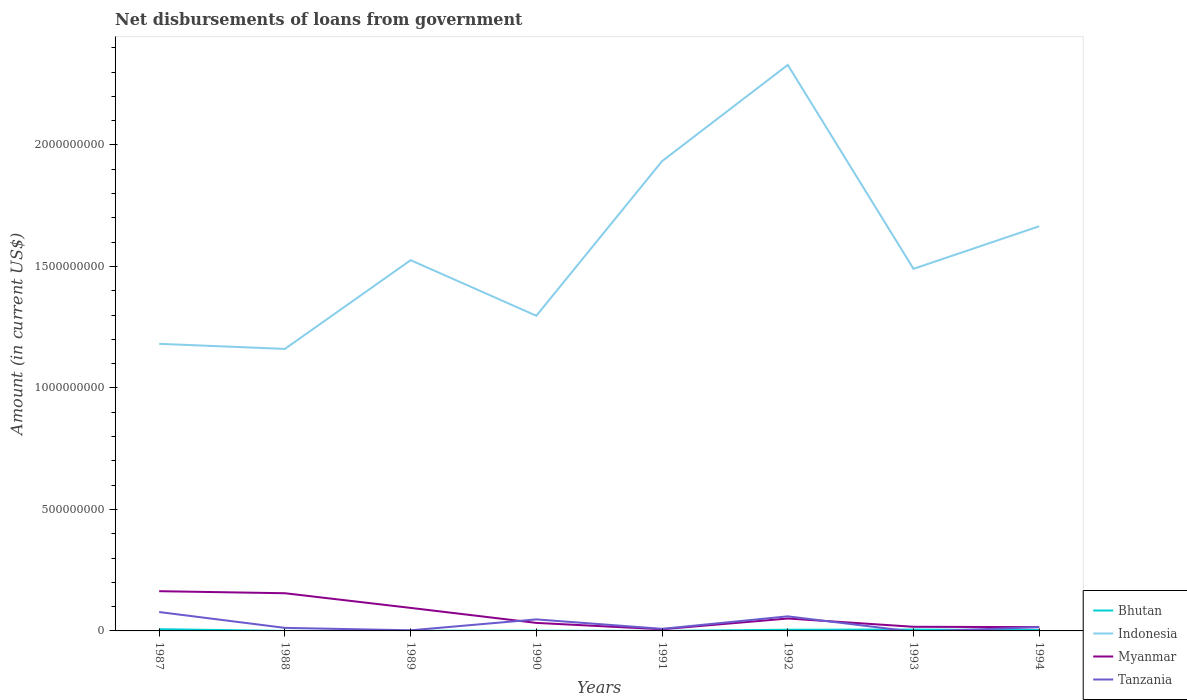How many different coloured lines are there?
Offer a very short reply. 4. Does the line corresponding to Myanmar intersect with the line corresponding to Bhutan?
Give a very brief answer. No. Is the number of lines equal to the number of legend labels?
Your answer should be compact. No. Across all years, what is the maximum amount of loan disbursed from government in Tanzania?
Your answer should be very brief. 0. What is the total amount of loan disbursed from government in Tanzania in the graph?
Provide a short and direct response. 6.51e+07. What is the difference between the highest and the second highest amount of loan disbursed from government in Bhutan?
Offer a very short reply. 7.10e+06. What is the difference between the highest and the lowest amount of loan disbursed from government in Indonesia?
Provide a short and direct response. 3. Is the amount of loan disbursed from government in Myanmar strictly greater than the amount of loan disbursed from government in Bhutan over the years?
Your response must be concise. No. How many lines are there?
Offer a very short reply. 4. What is the difference between two consecutive major ticks on the Y-axis?
Keep it short and to the point. 5.00e+08. Are the values on the major ticks of Y-axis written in scientific E-notation?
Your response must be concise. No. Does the graph contain grids?
Give a very brief answer. No. Where does the legend appear in the graph?
Your answer should be compact. Bottom right. How are the legend labels stacked?
Give a very brief answer. Vertical. What is the title of the graph?
Your response must be concise. Net disbursements of loans from government. What is the Amount (in current US$) of Bhutan in 1987?
Make the answer very short. 7.11e+06. What is the Amount (in current US$) in Indonesia in 1987?
Make the answer very short. 1.18e+09. What is the Amount (in current US$) in Myanmar in 1987?
Provide a succinct answer. 1.64e+08. What is the Amount (in current US$) in Tanzania in 1987?
Your response must be concise. 7.77e+07. What is the Amount (in current US$) of Bhutan in 1988?
Your response must be concise. 7000. What is the Amount (in current US$) in Indonesia in 1988?
Provide a short and direct response. 1.16e+09. What is the Amount (in current US$) of Myanmar in 1988?
Your answer should be very brief. 1.55e+08. What is the Amount (in current US$) of Tanzania in 1988?
Keep it short and to the point. 1.25e+07. What is the Amount (in current US$) in Bhutan in 1989?
Ensure brevity in your answer.  6.94e+05. What is the Amount (in current US$) of Indonesia in 1989?
Your response must be concise. 1.53e+09. What is the Amount (in current US$) in Myanmar in 1989?
Provide a short and direct response. 9.48e+07. What is the Amount (in current US$) in Tanzania in 1989?
Give a very brief answer. 2.54e+06. What is the Amount (in current US$) of Bhutan in 1990?
Your answer should be very brief. 9.27e+05. What is the Amount (in current US$) of Indonesia in 1990?
Offer a very short reply. 1.30e+09. What is the Amount (in current US$) of Myanmar in 1990?
Provide a succinct answer. 3.30e+07. What is the Amount (in current US$) in Tanzania in 1990?
Offer a very short reply. 4.74e+07. What is the Amount (in current US$) in Bhutan in 1991?
Make the answer very short. 6.90e+04. What is the Amount (in current US$) in Indonesia in 1991?
Give a very brief answer. 1.93e+09. What is the Amount (in current US$) of Myanmar in 1991?
Make the answer very short. 6.85e+06. What is the Amount (in current US$) of Tanzania in 1991?
Make the answer very short. 8.54e+06. What is the Amount (in current US$) of Bhutan in 1992?
Your response must be concise. 4.94e+06. What is the Amount (in current US$) in Indonesia in 1992?
Ensure brevity in your answer.  2.33e+09. What is the Amount (in current US$) in Myanmar in 1992?
Provide a succinct answer. 5.11e+07. What is the Amount (in current US$) of Tanzania in 1992?
Your answer should be compact. 6.00e+07. What is the Amount (in current US$) in Bhutan in 1993?
Give a very brief answer. 5.61e+06. What is the Amount (in current US$) of Indonesia in 1993?
Your answer should be compact. 1.49e+09. What is the Amount (in current US$) of Myanmar in 1993?
Offer a terse response. 1.70e+07. What is the Amount (in current US$) of Tanzania in 1993?
Offer a terse response. 0. What is the Amount (in current US$) of Bhutan in 1994?
Provide a succinct answer. 3.74e+06. What is the Amount (in current US$) of Indonesia in 1994?
Make the answer very short. 1.67e+09. What is the Amount (in current US$) of Myanmar in 1994?
Offer a terse response. 1.55e+07. What is the Amount (in current US$) of Tanzania in 1994?
Offer a very short reply. 1.55e+07. Across all years, what is the maximum Amount (in current US$) in Bhutan?
Offer a very short reply. 7.11e+06. Across all years, what is the maximum Amount (in current US$) of Indonesia?
Your response must be concise. 2.33e+09. Across all years, what is the maximum Amount (in current US$) of Myanmar?
Give a very brief answer. 1.64e+08. Across all years, what is the maximum Amount (in current US$) of Tanzania?
Offer a terse response. 7.77e+07. Across all years, what is the minimum Amount (in current US$) in Bhutan?
Your answer should be very brief. 7000. Across all years, what is the minimum Amount (in current US$) in Indonesia?
Your answer should be compact. 1.16e+09. Across all years, what is the minimum Amount (in current US$) of Myanmar?
Your response must be concise. 6.85e+06. What is the total Amount (in current US$) in Bhutan in the graph?
Make the answer very short. 2.31e+07. What is the total Amount (in current US$) of Indonesia in the graph?
Your answer should be compact. 1.26e+1. What is the total Amount (in current US$) in Myanmar in the graph?
Your response must be concise. 5.37e+08. What is the total Amount (in current US$) of Tanzania in the graph?
Make the answer very short. 2.24e+08. What is the difference between the Amount (in current US$) in Bhutan in 1987 and that in 1988?
Provide a succinct answer. 7.10e+06. What is the difference between the Amount (in current US$) of Indonesia in 1987 and that in 1988?
Offer a terse response. 2.09e+07. What is the difference between the Amount (in current US$) of Myanmar in 1987 and that in 1988?
Your answer should be compact. 8.43e+06. What is the difference between the Amount (in current US$) in Tanzania in 1987 and that in 1988?
Ensure brevity in your answer.  6.51e+07. What is the difference between the Amount (in current US$) in Bhutan in 1987 and that in 1989?
Provide a short and direct response. 6.42e+06. What is the difference between the Amount (in current US$) of Indonesia in 1987 and that in 1989?
Your response must be concise. -3.44e+08. What is the difference between the Amount (in current US$) of Myanmar in 1987 and that in 1989?
Your response must be concise. 6.88e+07. What is the difference between the Amount (in current US$) in Tanzania in 1987 and that in 1989?
Make the answer very short. 7.52e+07. What is the difference between the Amount (in current US$) of Bhutan in 1987 and that in 1990?
Make the answer very short. 6.18e+06. What is the difference between the Amount (in current US$) of Indonesia in 1987 and that in 1990?
Your answer should be very brief. -1.16e+08. What is the difference between the Amount (in current US$) in Myanmar in 1987 and that in 1990?
Offer a very short reply. 1.31e+08. What is the difference between the Amount (in current US$) of Tanzania in 1987 and that in 1990?
Offer a very short reply. 3.02e+07. What is the difference between the Amount (in current US$) in Bhutan in 1987 and that in 1991?
Offer a terse response. 7.04e+06. What is the difference between the Amount (in current US$) of Indonesia in 1987 and that in 1991?
Make the answer very short. -7.52e+08. What is the difference between the Amount (in current US$) in Myanmar in 1987 and that in 1991?
Your answer should be very brief. 1.57e+08. What is the difference between the Amount (in current US$) of Tanzania in 1987 and that in 1991?
Offer a terse response. 6.92e+07. What is the difference between the Amount (in current US$) of Bhutan in 1987 and that in 1992?
Offer a terse response. 2.18e+06. What is the difference between the Amount (in current US$) of Indonesia in 1987 and that in 1992?
Offer a very short reply. -1.15e+09. What is the difference between the Amount (in current US$) in Myanmar in 1987 and that in 1992?
Ensure brevity in your answer.  1.12e+08. What is the difference between the Amount (in current US$) in Tanzania in 1987 and that in 1992?
Give a very brief answer. 1.77e+07. What is the difference between the Amount (in current US$) of Bhutan in 1987 and that in 1993?
Keep it short and to the point. 1.50e+06. What is the difference between the Amount (in current US$) in Indonesia in 1987 and that in 1993?
Ensure brevity in your answer.  -3.09e+08. What is the difference between the Amount (in current US$) in Myanmar in 1987 and that in 1993?
Make the answer very short. 1.47e+08. What is the difference between the Amount (in current US$) in Bhutan in 1987 and that in 1994?
Provide a succinct answer. 3.37e+06. What is the difference between the Amount (in current US$) in Indonesia in 1987 and that in 1994?
Ensure brevity in your answer.  -4.84e+08. What is the difference between the Amount (in current US$) of Myanmar in 1987 and that in 1994?
Ensure brevity in your answer.  1.48e+08. What is the difference between the Amount (in current US$) in Tanzania in 1987 and that in 1994?
Give a very brief answer. 6.22e+07. What is the difference between the Amount (in current US$) of Bhutan in 1988 and that in 1989?
Make the answer very short. -6.87e+05. What is the difference between the Amount (in current US$) of Indonesia in 1988 and that in 1989?
Give a very brief answer. -3.65e+08. What is the difference between the Amount (in current US$) in Myanmar in 1988 and that in 1989?
Offer a terse response. 6.04e+07. What is the difference between the Amount (in current US$) of Tanzania in 1988 and that in 1989?
Provide a succinct answer. 1.00e+07. What is the difference between the Amount (in current US$) of Bhutan in 1988 and that in 1990?
Ensure brevity in your answer.  -9.20e+05. What is the difference between the Amount (in current US$) of Indonesia in 1988 and that in 1990?
Provide a short and direct response. -1.36e+08. What is the difference between the Amount (in current US$) in Myanmar in 1988 and that in 1990?
Provide a succinct answer. 1.22e+08. What is the difference between the Amount (in current US$) in Tanzania in 1988 and that in 1990?
Make the answer very short. -3.49e+07. What is the difference between the Amount (in current US$) in Bhutan in 1988 and that in 1991?
Provide a short and direct response. -6.20e+04. What is the difference between the Amount (in current US$) of Indonesia in 1988 and that in 1991?
Keep it short and to the point. -7.73e+08. What is the difference between the Amount (in current US$) of Myanmar in 1988 and that in 1991?
Ensure brevity in your answer.  1.48e+08. What is the difference between the Amount (in current US$) in Tanzania in 1988 and that in 1991?
Provide a succinct answer. 4.00e+06. What is the difference between the Amount (in current US$) in Bhutan in 1988 and that in 1992?
Your response must be concise. -4.93e+06. What is the difference between the Amount (in current US$) of Indonesia in 1988 and that in 1992?
Provide a short and direct response. -1.17e+09. What is the difference between the Amount (in current US$) of Myanmar in 1988 and that in 1992?
Make the answer very short. 1.04e+08. What is the difference between the Amount (in current US$) of Tanzania in 1988 and that in 1992?
Provide a short and direct response. -4.74e+07. What is the difference between the Amount (in current US$) in Bhutan in 1988 and that in 1993?
Make the answer very short. -5.60e+06. What is the difference between the Amount (in current US$) in Indonesia in 1988 and that in 1993?
Ensure brevity in your answer.  -3.30e+08. What is the difference between the Amount (in current US$) in Myanmar in 1988 and that in 1993?
Provide a short and direct response. 1.38e+08. What is the difference between the Amount (in current US$) in Bhutan in 1988 and that in 1994?
Make the answer very short. -3.73e+06. What is the difference between the Amount (in current US$) in Indonesia in 1988 and that in 1994?
Offer a terse response. -5.05e+08. What is the difference between the Amount (in current US$) in Myanmar in 1988 and that in 1994?
Make the answer very short. 1.40e+08. What is the difference between the Amount (in current US$) of Tanzania in 1988 and that in 1994?
Offer a very short reply. -2.97e+06. What is the difference between the Amount (in current US$) of Bhutan in 1989 and that in 1990?
Offer a terse response. -2.33e+05. What is the difference between the Amount (in current US$) of Indonesia in 1989 and that in 1990?
Ensure brevity in your answer.  2.29e+08. What is the difference between the Amount (in current US$) of Myanmar in 1989 and that in 1990?
Your answer should be very brief. 6.18e+07. What is the difference between the Amount (in current US$) of Tanzania in 1989 and that in 1990?
Your answer should be very brief. -4.49e+07. What is the difference between the Amount (in current US$) in Bhutan in 1989 and that in 1991?
Your answer should be very brief. 6.25e+05. What is the difference between the Amount (in current US$) in Indonesia in 1989 and that in 1991?
Make the answer very short. -4.08e+08. What is the difference between the Amount (in current US$) of Myanmar in 1989 and that in 1991?
Offer a very short reply. 8.79e+07. What is the difference between the Amount (in current US$) in Tanzania in 1989 and that in 1991?
Provide a succinct answer. -6.00e+06. What is the difference between the Amount (in current US$) in Bhutan in 1989 and that in 1992?
Offer a very short reply. -4.24e+06. What is the difference between the Amount (in current US$) of Indonesia in 1989 and that in 1992?
Make the answer very short. -8.04e+08. What is the difference between the Amount (in current US$) in Myanmar in 1989 and that in 1992?
Your answer should be very brief. 4.37e+07. What is the difference between the Amount (in current US$) of Tanzania in 1989 and that in 1992?
Offer a terse response. -5.74e+07. What is the difference between the Amount (in current US$) of Bhutan in 1989 and that in 1993?
Offer a very short reply. -4.92e+06. What is the difference between the Amount (in current US$) in Indonesia in 1989 and that in 1993?
Keep it short and to the point. 3.55e+07. What is the difference between the Amount (in current US$) in Myanmar in 1989 and that in 1993?
Make the answer very short. 7.77e+07. What is the difference between the Amount (in current US$) of Bhutan in 1989 and that in 1994?
Keep it short and to the point. -3.05e+06. What is the difference between the Amount (in current US$) in Indonesia in 1989 and that in 1994?
Your answer should be very brief. -1.40e+08. What is the difference between the Amount (in current US$) in Myanmar in 1989 and that in 1994?
Provide a short and direct response. 7.92e+07. What is the difference between the Amount (in current US$) of Tanzania in 1989 and that in 1994?
Make the answer very short. -1.30e+07. What is the difference between the Amount (in current US$) of Bhutan in 1990 and that in 1991?
Give a very brief answer. 8.58e+05. What is the difference between the Amount (in current US$) in Indonesia in 1990 and that in 1991?
Provide a succinct answer. -6.36e+08. What is the difference between the Amount (in current US$) in Myanmar in 1990 and that in 1991?
Give a very brief answer. 2.62e+07. What is the difference between the Amount (in current US$) in Tanzania in 1990 and that in 1991?
Offer a terse response. 3.89e+07. What is the difference between the Amount (in current US$) in Bhutan in 1990 and that in 1992?
Your response must be concise. -4.01e+06. What is the difference between the Amount (in current US$) of Indonesia in 1990 and that in 1992?
Your response must be concise. -1.03e+09. What is the difference between the Amount (in current US$) in Myanmar in 1990 and that in 1992?
Your answer should be very brief. -1.81e+07. What is the difference between the Amount (in current US$) in Tanzania in 1990 and that in 1992?
Your response must be concise. -1.25e+07. What is the difference between the Amount (in current US$) in Bhutan in 1990 and that in 1993?
Offer a very short reply. -4.68e+06. What is the difference between the Amount (in current US$) in Indonesia in 1990 and that in 1993?
Make the answer very short. -1.93e+08. What is the difference between the Amount (in current US$) of Myanmar in 1990 and that in 1993?
Your answer should be compact. 1.60e+07. What is the difference between the Amount (in current US$) in Bhutan in 1990 and that in 1994?
Offer a very short reply. -2.81e+06. What is the difference between the Amount (in current US$) of Indonesia in 1990 and that in 1994?
Your answer should be very brief. -3.68e+08. What is the difference between the Amount (in current US$) of Myanmar in 1990 and that in 1994?
Ensure brevity in your answer.  1.75e+07. What is the difference between the Amount (in current US$) of Tanzania in 1990 and that in 1994?
Give a very brief answer. 3.19e+07. What is the difference between the Amount (in current US$) of Bhutan in 1991 and that in 1992?
Provide a short and direct response. -4.87e+06. What is the difference between the Amount (in current US$) of Indonesia in 1991 and that in 1992?
Your answer should be compact. -3.96e+08. What is the difference between the Amount (in current US$) in Myanmar in 1991 and that in 1992?
Keep it short and to the point. -4.42e+07. What is the difference between the Amount (in current US$) of Tanzania in 1991 and that in 1992?
Make the answer very short. -5.14e+07. What is the difference between the Amount (in current US$) in Bhutan in 1991 and that in 1993?
Offer a terse response. -5.54e+06. What is the difference between the Amount (in current US$) of Indonesia in 1991 and that in 1993?
Offer a very short reply. 4.43e+08. What is the difference between the Amount (in current US$) of Myanmar in 1991 and that in 1993?
Provide a succinct answer. -1.02e+07. What is the difference between the Amount (in current US$) in Bhutan in 1991 and that in 1994?
Give a very brief answer. -3.67e+06. What is the difference between the Amount (in current US$) of Indonesia in 1991 and that in 1994?
Your answer should be compact. 2.68e+08. What is the difference between the Amount (in current US$) of Myanmar in 1991 and that in 1994?
Offer a terse response. -8.68e+06. What is the difference between the Amount (in current US$) in Tanzania in 1991 and that in 1994?
Ensure brevity in your answer.  -6.98e+06. What is the difference between the Amount (in current US$) of Bhutan in 1992 and that in 1993?
Ensure brevity in your answer.  -6.75e+05. What is the difference between the Amount (in current US$) of Indonesia in 1992 and that in 1993?
Ensure brevity in your answer.  8.39e+08. What is the difference between the Amount (in current US$) in Myanmar in 1992 and that in 1993?
Keep it short and to the point. 3.41e+07. What is the difference between the Amount (in current US$) of Bhutan in 1992 and that in 1994?
Keep it short and to the point. 1.20e+06. What is the difference between the Amount (in current US$) in Indonesia in 1992 and that in 1994?
Ensure brevity in your answer.  6.64e+08. What is the difference between the Amount (in current US$) in Myanmar in 1992 and that in 1994?
Ensure brevity in your answer.  3.56e+07. What is the difference between the Amount (in current US$) in Tanzania in 1992 and that in 1994?
Offer a terse response. 4.45e+07. What is the difference between the Amount (in current US$) of Bhutan in 1993 and that in 1994?
Give a very brief answer. 1.87e+06. What is the difference between the Amount (in current US$) in Indonesia in 1993 and that in 1994?
Offer a very short reply. -1.75e+08. What is the difference between the Amount (in current US$) in Myanmar in 1993 and that in 1994?
Give a very brief answer. 1.50e+06. What is the difference between the Amount (in current US$) in Bhutan in 1987 and the Amount (in current US$) in Indonesia in 1988?
Keep it short and to the point. -1.15e+09. What is the difference between the Amount (in current US$) in Bhutan in 1987 and the Amount (in current US$) in Myanmar in 1988?
Your response must be concise. -1.48e+08. What is the difference between the Amount (in current US$) in Bhutan in 1987 and the Amount (in current US$) in Tanzania in 1988?
Keep it short and to the point. -5.44e+06. What is the difference between the Amount (in current US$) of Indonesia in 1987 and the Amount (in current US$) of Myanmar in 1988?
Keep it short and to the point. 1.03e+09. What is the difference between the Amount (in current US$) in Indonesia in 1987 and the Amount (in current US$) in Tanzania in 1988?
Offer a very short reply. 1.17e+09. What is the difference between the Amount (in current US$) in Myanmar in 1987 and the Amount (in current US$) in Tanzania in 1988?
Your response must be concise. 1.51e+08. What is the difference between the Amount (in current US$) of Bhutan in 1987 and the Amount (in current US$) of Indonesia in 1989?
Your answer should be compact. -1.52e+09. What is the difference between the Amount (in current US$) in Bhutan in 1987 and the Amount (in current US$) in Myanmar in 1989?
Offer a terse response. -8.77e+07. What is the difference between the Amount (in current US$) in Bhutan in 1987 and the Amount (in current US$) in Tanzania in 1989?
Provide a short and direct response. 4.57e+06. What is the difference between the Amount (in current US$) of Indonesia in 1987 and the Amount (in current US$) of Myanmar in 1989?
Your answer should be compact. 1.09e+09. What is the difference between the Amount (in current US$) in Indonesia in 1987 and the Amount (in current US$) in Tanzania in 1989?
Keep it short and to the point. 1.18e+09. What is the difference between the Amount (in current US$) of Myanmar in 1987 and the Amount (in current US$) of Tanzania in 1989?
Make the answer very short. 1.61e+08. What is the difference between the Amount (in current US$) in Bhutan in 1987 and the Amount (in current US$) in Indonesia in 1990?
Your response must be concise. -1.29e+09. What is the difference between the Amount (in current US$) in Bhutan in 1987 and the Amount (in current US$) in Myanmar in 1990?
Your answer should be compact. -2.59e+07. What is the difference between the Amount (in current US$) in Bhutan in 1987 and the Amount (in current US$) in Tanzania in 1990?
Your answer should be very brief. -4.03e+07. What is the difference between the Amount (in current US$) in Indonesia in 1987 and the Amount (in current US$) in Myanmar in 1990?
Provide a succinct answer. 1.15e+09. What is the difference between the Amount (in current US$) in Indonesia in 1987 and the Amount (in current US$) in Tanzania in 1990?
Offer a terse response. 1.13e+09. What is the difference between the Amount (in current US$) in Myanmar in 1987 and the Amount (in current US$) in Tanzania in 1990?
Your answer should be very brief. 1.16e+08. What is the difference between the Amount (in current US$) of Bhutan in 1987 and the Amount (in current US$) of Indonesia in 1991?
Your answer should be very brief. -1.93e+09. What is the difference between the Amount (in current US$) of Bhutan in 1987 and the Amount (in current US$) of Myanmar in 1991?
Offer a very short reply. 2.64e+05. What is the difference between the Amount (in current US$) in Bhutan in 1987 and the Amount (in current US$) in Tanzania in 1991?
Keep it short and to the point. -1.43e+06. What is the difference between the Amount (in current US$) in Indonesia in 1987 and the Amount (in current US$) in Myanmar in 1991?
Your response must be concise. 1.17e+09. What is the difference between the Amount (in current US$) of Indonesia in 1987 and the Amount (in current US$) of Tanzania in 1991?
Give a very brief answer. 1.17e+09. What is the difference between the Amount (in current US$) of Myanmar in 1987 and the Amount (in current US$) of Tanzania in 1991?
Keep it short and to the point. 1.55e+08. What is the difference between the Amount (in current US$) in Bhutan in 1987 and the Amount (in current US$) in Indonesia in 1992?
Keep it short and to the point. -2.32e+09. What is the difference between the Amount (in current US$) in Bhutan in 1987 and the Amount (in current US$) in Myanmar in 1992?
Offer a very short reply. -4.40e+07. What is the difference between the Amount (in current US$) of Bhutan in 1987 and the Amount (in current US$) of Tanzania in 1992?
Provide a succinct answer. -5.29e+07. What is the difference between the Amount (in current US$) in Indonesia in 1987 and the Amount (in current US$) in Myanmar in 1992?
Provide a succinct answer. 1.13e+09. What is the difference between the Amount (in current US$) in Indonesia in 1987 and the Amount (in current US$) in Tanzania in 1992?
Ensure brevity in your answer.  1.12e+09. What is the difference between the Amount (in current US$) of Myanmar in 1987 and the Amount (in current US$) of Tanzania in 1992?
Provide a short and direct response. 1.04e+08. What is the difference between the Amount (in current US$) of Bhutan in 1987 and the Amount (in current US$) of Indonesia in 1993?
Ensure brevity in your answer.  -1.48e+09. What is the difference between the Amount (in current US$) of Bhutan in 1987 and the Amount (in current US$) of Myanmar in 1993?
Offer a very short reply. -9.92e+06. What is the difference between the Amount (in current US$) in Indonesia in 1987 and the Amount (in current US$) in Myanmar in 1993?
Offer a very short reply. 1.16e+09. What is the difference between the Amount (in current US$) in Bhutan in 1987 and the Amount (in current US$) in Indonesia in 1994?
Give a very brief answer. -1.66e+09. What is the difference between the Amount (in current US$) of Bhutan in 1987 and the Amount (in current US$) of Myanmar in 1994?
Provide a succinct answer. -8.42e+06. What is the difference between the Amount (in current US$) in Bhutan in 1987 and the Amount (in current US$) in Tanzania in 1994?
Provide a short and direct response. -8.41e+06. What is the difference between the Amount (in current US$) in Indonesia in 1987 and the Amount (in current US$) in Myanmar in 1994?
Your answer should be very brief. 1.17e+09. What is the difference between the Amount (in current US$) in Indonesia in 1987 and the Amount (in current US$) in Tanzania in 1994?
Keep it short and to the point. 1.17e+09. What is the difference between the Amount (in current US$) in Myanmar in 1987 and the Amount (in current US$) in Tanzania in 1994?
Provide a short and direct response. 1.48e+08. What is the difference between the Amount (in current US$) in Bhutan in 1988 and the Amount (in current US$) in Indonesia in 1989?
Keep it short and to the point. -1.53e+09. What is the difference between the Amount (in current US$) of Bhutan in 1988 and the Amount (in current US$) of Myanmar in 1989?
Keep it short and to the point. -9.48e+07. What is the difference between the Amount (in current US$) in Bhutan in 1988 and the Amount (in current US$) in Tanzania in 1989?
Offer a very short reply. -2.53e+06. What is the difference between the Amount (in current US$) of Indonesia in 1988 and the Amount (in current US$) of Myanmar in 1989?
Provide a succinct answer. 1.07e+09. What is the difference between the Amount (in current US$) in Indonesia in 1988 and the Amount (in current US$) in Tanzania in 1989?
Provide a short and direct response. 1.16e+09. What is the difference between the Amount (in current US$) in Myanmar in 1988 and the Amount (in current US$) in Tanzania in 1989?
Your response must be concise. 1.53e+08. What is the difference between the Amount (in current US$) in Bhutan in 1988 and the Amount (in current US$) in Indonesia in 1990?
Offer a terse response. -1.30e+09. What is the difference between the Amount (in current US$) of Bhutan in 1988 and the Amount (in current US$) of Myanmar in 1990?
Keep it short and to the point. -3.30e+07. What is the difference between the Amount (in current US$) of Bhutan in 1988 and the Amount (in current US$) of Tanzania in 1990?
Ensure brevity in your answer.  -4.74e+07. What is the difference between the Amount (in current US$) of Indonesia in 1988 and the Amount (in current US$) of Myanmar in 1990?
Provide a succinct answer. 1.13e+09. What is the difference between the Amount (in current US$) of Indonesia in 1988 and the Amount (in current US$) of Tanzania in 1990?
Offer a terse response. 1.11e+09. What is the difference between the Amount (in current US$) of Myanmar in 1988 and the Amount (in current US$) of Tanzania in 1990?
Your answer should be very brief. 1.08e+08. What is the difference between the Amount (in current US$) of Bhutan in 1988 and the Amount (in current US$) of Indonesia in 1991?
Give a very brief answer. -1.93e+09. What is the difference between the Amount (in current US$) of Bhutan in 1988 and the Amount (in current US$) of Myanmar in 1991?
Give a very brief answer. -6.84e+06. What is the difference between the Amount (in current US$) in Bhutan in 1988 and the Amount (in current US$) in Tanzania in 1991?
Ensure brevity in your answer.  -8.54e+06. What is the difference between the Amount (in current US$) in Indonesia in 1988 and the Amount (in current US$) in Myanmar in 1991?
Provide a succinct answer. 1.15e+09. What is the difference between the Amount (in current US$) in Indonesia in 1988 and the Amount (in current US$) in Tanzania in 1991?
Offer a terse response. 1.15e+09. What is the difference between the Amount (in current US$) of Myanmar in 1988 and the Amount (in current US$) of Tanzania in 1991?
Offer a very short reply. 1.47e+08. What is the difference between the Amount (in current US$) of Bhutan in 1988 and the Amount (in current US$) of Indonesia in 1992?
Make the answer very short. -2.33e+09. What is the difference between the Amount (in current US$) of Bhutan in 1988 and the Amount (in current US$) of Myanmar in 1992?
Your answer should be very brief. -5.11e+07. What is the difference between the Amount (in current US$) of Bhutan in 1988 and the Amount (in current US$) of Tanzania in 1992?
Provide a succinct answer. -6.00e+07. What is the difference between the Amount (in current US$) in Indonesia in 1988 and the Amount (in current US$) in Myanmar in 1992?
Provide a short and direct response. 1.11e+09. What is the difference between the Amount (in current US$) in Indonesia in 1988 and the Amount (in current US$) in Tanzania in 1992?
Provide a short and direct response. 1.10e+09. What is the difference between the Amount (in current US$) in Myanmar in 1988 and the Amount (in current US$) in Tanzania in 1992?
Offer a terse response. 9.51e+07. What is the difference between the Amount (in current US$) of Bhutan in 1988 and the Amount (in current US$) of Indonesia in 1993?
Provide a short and direct response. -1.49e+09. What is the difference between the Amount (in current US$) in Bhutan in 1988 and the Amount (in current US$) in Myanmar in 1993?
Make the answer very short. -1.70e+07. What is the difference between the Amount (in current US$) in Indonesia in 1988 and the Amount (in current US$) in Myanmar in 1993?
Provide a succinct answer. 1.14e+09. What is the difference between the Amount (in current US$) in Bhutan in 1988 and the Amount (in current US$) in Indonesia in 1994?
Ensure brevity in your answer.  -1.67e+09. What is the difference between the Amount (in current US$) of Bhutan in 1988 and the Amount (in current US$) of Myanmar in 1994?
Your answer should be compact. -1.55e+07. What is the difference between the Amount (in current US$) in Bhutan in 1988 and the Amount (in current US$) in Tanzania in 1994?
Offer a terse response. -1.55e+07. What is the difference between the Amount (in current US$) in Indonesia in 1988 and the Amount (in current US$) in Myanmar in 1994?
Make the answer very short. 1.15e+09. What is the difference between the Amount (in current US$) in Indonesia in 1988 and the Amount (in current US$) in Tanzania in 1994?
Give a very brief answer. 1.15e+09. What is the difference between the Amount (in current US$) in Myanmar in 1988 and the Amount (in current US$) in Tanzania in 1994?
Ensure brevity in your answer.  1.40e+08. What is the difference between the Amount (in current US$) of Bhutan in 1989 and the Amount (in current US$) of Indonesia in 1990?
Your answer should be very brief. -1.30e+09. What is the difference between the Amount (in current US$) in Bhutan in 1989 and the Amount (in current US$) in Myanmar in 1990?
Provide a succinct answer. -3.23e+07. What is the difference between the Amount (in current US$) in Bhutan in 1989 and the Amount (in current US$) in Tanzania in 1990?
Provide a short and direct response. -4.68e+07. What is the difference between the Amount (in current US$) of Indonesia in 1989 and the Amount (in current US$) of Myanmar in 1990?
Offer a terse response. 1.49e+09. What is the difference between the Amount (in current US$) of Indonesia in 1989 and the Amount (in current US$) of Tanzania in 1990?
Your answer should be compact. 1.48e+09. What is the difference between the Amount (in current US$) of Myanmar in 1989 and the Amount (in current US$) of Tanzania in 1990?
Give a very brief answer. 4.73e+07. What is the difference between the Amount (in current US$) in Bhutan in 1989 and the Amount (in current US$) in Indonesia in 1991?
Offer a very short reply. -1.93e+09. What is the difference between the Amount (in current US$) in Bhutan in 1989 and the Amount (in current US$) in Myanmar in 1991?
Keep it short and to the point. -6.15e+06. What is the difference between the Amount (in current US$) of Bhutan in 1989 and the Amount (in current US$) of Tanzania in 1991?
Provide a short and direct response. -7.85e+06. What is the difference between the Amount (in current US$) of Indonesia in 1989 and the Amount (in current US$) of Myanmar in 1991?
Your answer should be very brief. 1.52e+09. What is the difference between the Amount (in current US$) of Indonesia in 1989 and the Amount (in current US$) of Tanzania in 1991?
Ensure brevity in your answer.  1.52e+09. What is the difference between the Amount (in current US$) in Myanmar in 1989 and the Amount (in current US$) in Tanzania in 1991?
Provide a short and direct response. 8.62e+07. What is the difference between the Amount (in current US$) of Bhutan in 1989 and the Amount (in current US$) of Indonesia in 1992?
Offer a terse response. -2.33e+09. What is the difference between the Amount (in current US$) in Bhutan in 1989 and the Amount (in current US$) in Myanmar in 1992?
Your response must be concise. -5.04e+07. What is the difference between the Amount (in current US$) of Bhutan in 1989 and the Amount (in current US$) of Tanzania in 1992?
Make the answer very short. -5.93e+07. What is the difference between the Amount (in current US$) in Indonesia in 1989 and the Amount (in current US$) in Myanmar in 1992?
Offer a very short reply. 1.47e+09. What is the difference between the Amount (in current US$) in Indonesia in 1989 and the Amount (in current US$) in Tanzania in 1992?
Ensure brevity in your answer.  1.47e+09. What is the difference between the Amount (in current US$) in Myanmar in 1989 and the Amount (in current US$) in Tanzania in 1992?
Provide a short and direct response. 3.48e+07. What is the difference between the Amount (in current US$) of Bhutan in 1989 and the Amount (in current US$) of Indonesia in 1993?
Offer a terse response. -1.49e+09. What is the difference between the Amount (in current US$) of Bhutan in 1989 and the Amount (in current US$) of Myanmar in 1993?
Your answer should be compact. -1.63e+07. What is the difference between the Amount (in current US$) in Indonesia in 1989 and the Amount (in current US$) in Myanmar in 1993?
Make the answer very short. 1.51e+09. What is the difference between the Amount (in current US$) of Bhutan in 1989 and the Amount (in current US$) of Indonesia in 1994?
Provide a succinct answer. -1.66e+09. What is the difference between the Amount (in current US$) in Bhutan in 1989 and the Amount (in current US$) in Myanmar in 1994?
Ensure brevity in your answer.  -1.48e+07. What is the difference between the Amount (in current US$) of Bhutan in 1989 and the Amount (in current US$) of Tanzania in 1994?
Your response must be concise. -1.48e+07. What is the difference between the Amount (in current US$) in Indonesia in 1989 and the Amount (in current US$) in Myanmar in 1994?
Your response must be concise. 1.51e+09. What is the difference between the Amount (in current US$) of Indonesia in 1989 and the Amount (in current US$) of Tanzania in 1994?
Your response must be concise. 1.51e+09. What is the difference between the Amount (in current US$) in Myanmar in 1989 and the Amount (in current US$) in Tanzania in 1994?
Make the answer very short. 7.92e+07. What is the difference between the Amount (in current US$) in Bhutan in 1990 and the Amount (in current US$) in Indonesia in 1991?
Give a very brief answer. -1.93e+09. What is the difference between the Amount (in current US$) in Bhutan in 1990 and the Amount (in current US$) in Myanmar in 1991?
Provide a short and direct response. -5.92e+06. What is the difference between the Amount (in current US$) in Bhutan in 1990 and the Amount (in current US$) in Tanzania in 1991?
Your response must be concise. -7.62e+06. What is the difference between the Amount (in current US$) in Indonesia in 1990 and the Amount (in current US$) in Myanmar in 1991?
Your response must be concise. 1.29e+09. What is the difference between the Amount (in current US$) in Indonesia in 1990 and the Amount (in current US$) in Tanzania in 1991?
Your answer should be very brief. 1.29e+09. What is the difference between the Amount (in current US$) in Myanmar in 1990 and the Amount (in current US$) in Tanzania in 1991?
Ensure brevity in your answer.  2.45e+07. What is the difference between the Amount (in current US$) in Bhutan in 1990 and the Amount (in current US$) in Indonesia in 1992?
Offer a very short reply. -2.33e+09. What is the difference between the Amount (in current US$) of Bhutan in 1990 and the Amount (in current US$) of Myanmar in 1992?
Provide a succinct answer. -5.02e+07. What is the difference between the Amount (in current US$) of Bhutan in 1990 and the Amount (in current US$) of Tanzania in 1992?
Ensure brevity in your answer.  -5.91e+07. What is the difference between the Amount (in current US$) of Indonesia in 1990 and the Amount (in current US$) of Myanmar in 1992?
Your response must be concise. 1.25e+09. What is the difference between the Amount (in current US$) of Indonesia in 1990 and the Amount (in current US$) of Tanzania in 1992?
Your answer should be very brief. 1.24e+09. What is the difference between the Amount (in current US$) in Myanmar in 1990 and the Amount (in current US$) in Tanzania in 1992?
Your answer should be compact. -2.70e+07. What is the difference between the Amount (in current US$) of Bhutan in 1990 and the Amount (in current US$) of Indonesia in 1993?
Ensure brevity in your answer.  -1.49e+09. What is the difference between the Amount (in current US$) in Bhutan in 1990 and the Amount (in current US$) in Myanmar in 1993?
Give a very brief answer. -1.61e+07. What is the difference between the Amount (in current US$) of Indonesia in 1990 and the Amount (in current US$) of Myanmar in 1993?
Make the answer very short. 1.28e+09. What is the difference between the Amount (in current US$) of Bhutan in 1990 and the Amount (in current US$) of Indonesia in 1994?
Make the answer very short. -1.66e+09. What is the difference between the Amount (in current US$) in Bhutan in 1990 and the Amount (in current US$) in Myanmar in 1994?
Offer a very short reply. -1.46e+07. What is the difference between the Amount (in current US$) of Bhutan in 1990 and the Amount (in current US$) of Tanzania in 1994?
Your response must be concise. -1.46e+07. What is the difference between the Amount (in current US$) in Indonesia in 1990 and the Amount (in current US$) in Myanmar in 1994?
Ensure brevity in your answer.  1.28e+09. What is the difference between the Amount (in current US$) of Indonesia in 1990 and the Amount (in current US$) of Tanzania in 1994?
Offer a very short reply. 1.28e+09. What is the difference between the Amount (in current US$) in Myanmar in 1990 and the Amount (in current US$) in Tanzania in 1994?
Your answer should be compact. 1.75e+07. What is the difference between the Amount (in current US$) in Bhutan in 1991 and the Amount (in current US$) in Indonesia in 1992?
Offer a very short reply. -2.33e+09. What is the difference between the Amount (in current US$) of Bhutan in 1991 and the Amount (in current US$) of Myanmar in 1992?
Make the answer very short. -5.10e+07. What is the difference between the Amount (in current US$) of Bhutan in 1991 and the Amount (in current US$) of Tanzania in 1992?
Keep it short and to the point. -5.99e+07. What is the difference between the Amount (in current US$) in Indonesia in 1991 and the Amount (in current US$) in Myanmar in 1992?
Provide a succinct answer. 1.88e+09. What is the difference between the Amount (in current US$) of Indonesia in 1991 and the Amount (in current US$) of Tanzania in 1992?
Offer a terse response. 1.87e+09. What is the difference between the Amount (in current US$) of Myanmar in 1991 and the Amount (in current US$) of Tanzania in 1992?
Keep it short and to the point. -5.31e+07. What is the difference between the Amount (in current US$) of Bhutan in 1991 and the Amount (in current US$) of Indonesia in 1993?
Your response must be concise. -1.49e+09. What is the difference between the Amount (in current US$) of Bhutan in 1991 and the Amount (in current US$) of Myanmar in 1993?
Your answer should be very brief. -1.70e+07. What is the difference between the Amount (in current US$) of Indonesia in 1991 and the Amount (in current US$) of Myanmar in 1993?
Offer a terse response. 1.92e+09. What is the difference between the Amount (in current US$) of Bhutan in 1991 and the Amount (in current US$) of Indonesia in 1994?
Offer a terse response. -1.67e+09. What is the difference between the Amount (in current US$) of Bhutan in 1991 and the Amount (in current US$) of Myanmar in 1994?
Your answer should be compact. -1.55e+07. What is the difference between the Amount (in current US$) of Bhutan in 1991 and the Amount (in current US$) of Tanzania in 1994?
Your answer should be very brief. -1.54e+07. What is the difference between the Amount (in current US$) of Indonesia in 1991 and the Amount (in current US$) of Myanmar in 1994?
Give a very brief answer. 1.92e+09. What is the difference between the Amount (in current US$) of Indonesia in 1991 and the Amount (in current US$) of Tanzania in 1994?
Provide a succinct answer. 1.92e+09. What is the difference between the Amount (in current US$) in Myanmar in 1991 and the Amount (in current US$) in Tanzania in 1994?
Give a very brief answer. -8.67e+06. What is the difference between the Amount (in current US$) in Bhutan in 1992 and the Amount (in current US$) in Indonesia in 1993?
Offer a terse response. -1.49e+09. What is the difference between the Amount (in current US$) in Bhutan in 1992 and the Amount (in current US$) in Myanmar in 1993?
Your answer should be compact. -1.21e+07. What is the difference between the Amount (in current US$) in Indonesia in 1992 and the Amount (in current US$) in Myanmar in 1993?
Make the answer very short. 2.31e+09. What is the difference between the Amount (in current US$) in Bhutan in 1992 and the Amount (in current US$) in Indonesia in 1994?
Offer a very short reply. -1.66e+09. What is the difference between the Amount (in current US$) in Bhutan in 1992 and the Amount (in current US$) in Myanmar in 1994?
Provide a short and direct response. -1.06e+07. What is the difference between the Amount (in current US$) in Bhutan in 1992 and the Amount (in current US$) in Tanzania in 1994?
Give a very brief answer. -1.06e+07. What is the difference between the Amount (in current US$) in Indonesia in 1992 and the Amount (in current US$) in Myanmar in 1994?
Offer a terse response. 2.31e+09. What is the difference between the Amount (in current US$) in Indonesia in 1992 and the Amount (in current US$) in Tanzania in 1994?
Make the answer very short. 2.31e+09. What is the difference between the Amount (in current US$) of Myanmar in 1992 and the Amount (in current US$) of Tanzania in 1994?
Keep it short and to the point. 3.56e+07. What is the difference between the Amount (in current US$) in Bhutan in 1993 and the Amount (in current US$) in Indonesia in 1994?
Make the answer very short. -1.66e+09. What is the difference between the Amount (in current US$) in Bhutan in 1993 and the Amount (in current US$) in Myanmar in 1994?
Give a very brief answer. -9.92e+06. What is the difference between the Amount (in current US$) in Bhutan in 1993 and the Amount (in current US$) in Tanzania in 1994?
Provide a short and direct response. -9.91e+06. What is the difference between the Amount (in current US$) of Indonesia in 1993 and the Amount (in current US$) of Myanmar in 1994?
Offer a very short reply. 1.47e+09. What is the difference between the Amount (in current US$) in Indonesia in 1993 and the Amount (in current US$) in Tanzania in 1994?
Your answer should be very brief. 1.47e+09. What is the difference between the Amount (in current US$) in Myanmar in 1993 and the Amount (in current US$) in Tanzania in 1994?
Ensure brevity in your answer.  1.51e+06. What is the average Amount (in current US$) of Bhutan per year?
Make the answer very short. 2.89e+06. What is the average Amount (in current US$) in Indonesia per year?
Your answer should be very brief. 1.57e+09. What is the average Amount (in current US$) in Myanmar per year?
Your answer should be compact. 6.71e+07. What is the average Amount (in current US$) in Tanzania per year?
Offer a terse response. 2.80e+07. In the year 1987, what is the difference between the Amount (in current US$) of Bhutan and Amount (in current US$) of Indonesia?
Provide a short and direct response. -1.17e+09. In the year 1987, what is the difference between the Amount (in current US$) of Bhutan and Amount (in current US$) of Myanmar?
Your answer should be very brief. -1.56e+08. In the year 1987, what is the difference between the Amount (in current US$) in Bhutan and Amount (in current US$) in Tanzania?
Ensure brevity in your answer.  -7.06e+07. In the year 1987, what is the difference between the Amount (in current US$) in Indonesia and Amount (in current US$) in Myanmar?
Provide a short and direct response. 1.02e+09. In the year 1987, what is the difference between the Amount (in current US$) of Indonesia and Amount (in current US$) of Tanzania?
Your response must be concise. 1.10e+09. In the year 1987, what is the difference between the Amount (in current US$) of Myanmar and Amount (in current US$) of Tanzania?
Make the answer very short. 8.59e+07. In the year 1988, what is the difference between the Amount (in current US$) in Bhutan and Amount (in current US$) in Indonesia?
Keep it short and to the point. -1.16e+09. In the year 1988, what is the difference between the Amount (in current US$) of Bhutan and Amount (in current US$) of Myanmar?
Keep it short and to the point. -1.55e+08. In the year 1988, what is the difference between the Amount (in current US$) of Bhutan and Amount (in current US$) of Tanzania?
Give a very brief answer. -1.25e+07. In the year 1988, what is the difference between the Amount (in current US$) in Indonesia and Amount (in current US$) in Myanmar?
Keep it short and to the point. 1.01e+09. In the year 1988, what is the difference between the Amount (in current US$) in Indonesia and Amount (in current US$) in Tanzania?
Your answer should be compact. 1.15e+09. In the year 1988, what is the difference between the Amount (in current US$) in Myanmar and Amount (in current US$) in Tanzania?
Provide a short and direct response. 1.43e+08. In the year 1989, what is the difference between the Amount (in current US$) of Bhutan and Amount (in current US$) of Indonesia?
Your answer should be compact. -1.53e+09. In the year 1989, what is the difference between the Amount (in current US$) of Bhutan and Amount (in current US$) of Myanmar?
Offer a very short reply. -9.41e+07. In the year 1989, what is the difference between the Amount (in current US$) in Bhutan and Amount (in current US$) in Tanzania?
Make the answer very short. -1.85e+06. In the year 1989, what is the difference between the Amount (in current US$) in Indonesia and Amount (in current US$) in Myanmar?
Provide a succinct answer. 1.43e+09. In the year 1989, what is the difference between the Amount (in current US$) of Indonesia and Amount (in current US$) of Tanzania?
Make the answer very short. 1.52e+09. In the year 1989, what is the difference between the Amount (in current US$) of Myanmar and Amount (in current US$) of Tanzania?
Your answer should be very brief. 9.22e+07. In the year 1990, what is the difference between the Amount (in current US$) in Bhutan and Amount (in current US$) in Indonesia?
Ensure brevity in your answer.  -1.30e+09. In the year 1990, what is the difference between the Amount (in current US$) in Bhutan and Amount (in current US$) in Myanmar?
Your answer should be compact. -3.21e+07. In the year 1990, what is the difference between the Amount (in current US$) in Bhutan and Amount (in current US$) in Tanzania?
Keep it short and to the point. -4.65e+07. In the year 1990, what is the difference between the Amount (in current US$) in Indonesia and Amount (in current US$) in Myanmar?
Make the answer very short. 1.26e+09. In the year 1990, what is the difference between the Amount (in current US$) in Indonesia and Amount (in current US$) in Tanzania?
Offer a terse response. 1.25e+09. In the year 1990, what is the difference between the Amount (in current US$) of Myanmar and Amount (in current US$) of Tanzania?
Your response must be concise. -1.44e+07. In the year 1991, what is the difference between the Amount (in current US$) of Bhutan and Amount (in current US$) of Indonesia?
Offer a very short reply. -1.93e+09. In the year 1991, what is the difference between the Amount (in current US$) in Bhutan and Amount (in current US$) in Myanmar?
Offer a very short reply. -6.78e+06. In the year 1991, what is the difference between the Amount (in current US$) in Bhutan and Amount (in current US$) in Tanzania?
Keep it short and to the point. -8.47e+06. In the year 1991, what is the difference between the Amount (in current US$) in Indonesia and Amount (in current US$) in Myanmar?
Ensure brevity in your answer.  1.93e+09. In the year 1991, what is the difference between the Amount (in current US$) in Indonesia and Amount (in current US$) in Tanzania?
Your response must be concise. 1.92e+09. In the year 1991, what is the difference between the Amount (in current US$) of Myanmar and Amount (in current US$) of Tanzania?
Your response must be concise. -1.70e+06. In the year 1992, what is the difference between the Amount (in current US$) of Bhutan and Amount (in current US$) of Indonesia?
Ensure brevity in your answer.  -2.32e+09. In the year 1992, what is the difference between the Amount (in current US$) in Bhutan and Amount (in current US$) in Myanmar?
Your answer should be very brief. -4.62e+07. In the year 1992, what is the difference between the Amount (in current US$) of Bhutan and Amount (in current US$) of Tanzania?
Offer a very short reply. -5.51e+07. In the year 1992, what is the difference between the Amount (in current US$) of Indonesia and Amount (in current US$) of Myanmar?
Provide a short and direct response. 2.28e+09. In the year 1992, what is the difference between the Amount (in current US$) of Indonesia and Amount (in current US$) of Tanzania?
Make the answer very short. 2.27e+09. In the year 1992, what is the difference between the Amount (in current US$) of Myanmar and Amount (in current US$) of Tanzania?
Offer a very short reply. -8.89e+06. In the year 1993, what is the difference between the Amount (in current US$) in Bhutan and Amount (in current US$) in Indonesia?
Ensure brevity in your answer.  -1.48e+09. In the year 1993, what is the difference between the Amount (in current US$) in Bhutan and Amount (in current US$) in Myanmar?
Ensure brevity in your answer.  -1.14e+07. In the year 1993, what is the difference between the Amount (in current US$) of Indonesia and Amount (in current US$) of Myanmar?
Your answer should be very brief. 1.47e+09. In the year 1994, what is the difference between the Amount (in current US$) in Bhutan and Amount (in current US$) in Indonesia?
Make the answer very short. -1.66e+09. In the year 1994, what is the difference between the Amount (in current US$) in Bhutan and Amount (in current US$) in Myanmar?
Make the answer very short. -1.18e+07. In the year 1994, what is the difference between the Amount (in current US$) of Bhutan and Amount (in current US$) of Tanzania?
Keep it short and to the point. -1.18e+07. In the year 1994, what is the difference between the Amount (in current US$) of Indonesia and Amount (in current US$) of Myanmar?
Offer a terse response. 1.65e+09. In the year 1994, what is the difference between the Amount (in current US$) of Indonesia and Amount (in current US$) of Tanzania?
Provide a short and direct response. 1.65e+09. In the year 1994, what is the difference between the Amount (in current US$) of Myanmar and Amount (in current US$) of Tanzania?
Ensure brevity in your answer.  1.40e+04. What is the ratio of the Amount (in current US$) of Bhutan in 1987 to that in 1988?
Provide a succinct answer. 1016. What is the ratio of the Amount (in current US$) in Myanmar in 1987 to that in 1988?
Keep it short and to the point. 1.05. What is the ratio of the Amount (in current US$) in Tanzania in 1987 to that in 1988?
Make the answer very short. 6.19. What is the ratio of the Amount (in current US$) in Bhutan in 1987 to that in 1989?
Your answer should be very brief. 10.25. What is the ratio of the Amount (in current US$) in Indonesia in 1987 to that in 1989?
Offer a terse response. 0.77. What is the ratio of the Amount (in current US$) of Myanmar in 1987 to that in 1989?
Make the answer very short. 1.73. What is the ratio of the Amount (in current US$) in Tanzania in 1987 to that in 1989?
Offer a very short reply. 30.58. What is the ratio of the Amount (in current US$) of Bhutan in 1987 to that in 1990?
Keep it short and to the point. 7.67. What is the ratio of the Amount (in current US$) of Indonesia in 1987 to that in 1990?
Keep it short and to the point. 0.91. What is the ratio of the Amount (in current US$) in Myanmar in 1987 to that in 1990?
Keep it short and to the point. 4.96. What is the ratio of the Amount (in current US$) in Tanzania in 1987 to that in 1990?
Keep it short and to the point. 1.64. What is the ratio of the Amount (in current US$) in Bhutan in 1987 to that in 1991?
Provide a short and direct response. 103.07. What is the ratio of the Amount (in current US$) in Indonesia in 1987 to that in 1991?
Make the answer very short. 0.61. What is the ratio of the Amount (in current US$) of Myanmar in 1987 to that in 1991?
Your answer should be compact. 23.88. What is the ratio of the Amount (in current US$) in Tanzania in 1987 to that in 1991?
Ensure brevity in your answer.  9.09. What is the ratio of the Amount (in current US$) of Bhutan in 1987 to that in 1992?
Provide a succinct answer. 1.44. What is the ratio of the Amount (in current US$) of Indonesia in 1987 to that in 1992?
Provide a succinct answer. 0.51. What is the ratio of the Amount (in current US$) in Myanmar in 1987 to that in 1992?
Make the answer very short. 3.2. What is the ratio of the Amount (in current US$) in Tanzania in 1987 to that in 1992?
Provide a succinct answer. 1.3. What is the ratio of the Amount (in current US$) in Bhutan in 1987 to that in 1993?
Give a very brief answer. 1.27. What is the ratio of the Amount (in current US$) in Indonesia in 1987 to that in 1993?
Make the answer very short. 0.79. What is the ratio of the Amount (in current US$) of Myanmar in 1987 to that in 1993?
Your response must be concise. 9.6. What is the ratio of the Amount (in current US$) of Bhutan in 1987 to that in 1994?
Your response must be concise. 1.9. What is the ratio of the Amount (in current US$) of Indonesia in 1987 to that in 1994?
Offer a terse response. 0.71. What is the ratio of the Amount (in current US$) of Myanmar in 1987 to that in 1994?
Your answer should be compact. 10.53. What is the ratio of the Amount (in current US$) of Tanzania in 1987 to that in 1994?
Offer a terse response. 5.01. What is the ratio of the Amount (in current US$) of Bhutan in 1988 to that in 1989?
Your answer should be compact. 0.01. What is the ratio of the Amount (in current US$) in Indonesia in 1988 to that in 1989?
Provide a succinct answer. 0.76. What is the ratio of the Amount (in current US$) of Myanmar in 1988 to that in 1989?
Your response must be concise. 1.64. What is the ratio of the Amount (in current US$) in Tanzania in 1988 to that in 1989?
Offer a terse response. 4.94. What is the ratio of the Amount (in current US$) in Bhutan in 1988 to that in 1990?
Offer a very short reply. 0.01. What is the ratio of the Amount (in current US$) in Indonesia in 1988 to that in 1990?
Make the answer very short. 0.89. What is the ratio of the Amount (in current US$) in Myanmar in 1988 to that in 1990?
Make the answer very short. 4.7. What is the ratio of the Amount (in current US$) of Tanzania in 1988 to that in 1990?
Your answer should be very brief. 0.26. What is the ratio of the Amount (in current US$) in Bhutan in 1988 to that in 1991?
Your answer should be very brief. 0.1. What is the ratio of the Amount (in current US$) in Indonesia in 1988 to that in 1991?
Keep it short and to the point. 0.6. What is the ratio of the Amount (in current US$) of Myanmar in 1988 to that in 1991?
Your answer should be compact. 22.65. What is the ratio of the Amount (in current US$) of Tanzania in 1988 to that in 1991?
Your response must be concise. 1.47. What is the ratio of the Amount (in current US$) in Bhutan in 1988 to that in 1992?
Make the answer very short. 0. What is the ratio of the Amount (in current US$) in Indonesia in 1988 to that in 1992?
Ensure brevity in your answer.  0.5. What is the ratio of the Amount (in current US$) in Myanmar in 1988 to that in 1992?
Provide a short and direct response. 3.04. What is the ratio of the Amount (in current US$) of Tanzania in 1988 to that in 1992?
Your answer should be very brief. 0.21. What is the ratio of the Amount (in current US$) of Bhutan in 1988 to that in 1993?
Give a very brief answer. 0. What is the ratio of the Amount (in current US$) in Indonesia in 1988 to that in 1993?
Ensure brevity in your answer.  0.78. What is the ratio of the Amount (in current US$) in Myanmar in 1988 to that in 1993?
Ensure brevity in your answer.  9.11. What is the ratio of the Amount (in current US$) in Bhutan in 1988 to that in 1994?
Your response must be concise. 0. What is the ratio of the Amount (in current US$) in Indonesia in 1988 to that in 1994?
Keep it short and to the point. 0.7. What is the ratio of the Amount (in current US$) of Myanmar in 1988 to that in 1994?
Your response must be concise. 9.99. What is the ratio of the Amount (in current US$) of Tanzania in 1988 to that in 1994?
Offer a terse response. 0.81. What is the ratio of the Amount (in current US$) of Bhutan in 1989 to that in 1990?
Your answer should be very brief. 0.75. What is the ratio of the Amount (in current US$) of Indonesia in 1989 to that in 1990?
Give a very brief answer. 1.18. What is the ratio of the Amount (in current US$) in Myanmar in 1989 to that in 1990?
Provide a succinct answer. 2.87. What is the ratio of the Amount (in current US$) of Tanzania in 1989 to that in 1990?
Your answer should be compact. 0.05. What is the ratio of the Amount (in current US$) of Bhutan in 1989 to that in 1991?
Offer a very short reply. 10.06. What is the ratio of the Amount (in current US$) of Indonesia in 1989 to that in 1991?
Ensure brevity in your answer.  0.79. What is the ratio of the Amount (in current US$) of Myanmar in 1989 to that in 1991?
Keep it short and to the point. 13.84. What is the ratio of the Amount (in current US$) in Tanzania in 1989 to that in 1991?
Give a very brief answer. 0.3. What is the ratio of the Amount (in current US$) of Bhutan in 1989 to that in 1992?
Provide a short and direct response. 0.14. What is the ratio of the Amount (in current US$) in Indonesia in 1989 to that in 1992?
Your answer should be compact. 0.66. What is the ratio of the Amount (in current US$) of Myanmar in 1989 to that in 1992?
Make the answer very short. 1.85. What is the ratio of the Amount (in current US$) in Tanzania in 1989 to that in 1992?
Your response must be concise. 0.04. What is the ratio of the Amount (in current US$) in Bhutan in 1989 to that in 1993?
Keep it short and to the point. 0.12. What is the ratio of the Amount (in current US$) of Indonesia in 1989 to that in 1993?
Keep it short and to the point. 1.02. What is the ratio of the Amount (in current US$) in Myanmar in 1989 to that in 1993?
Provide a short and direct response. 5.56. What is the ratio of the Amount (in current US$) of Bhutan in 1989 to that in 1994?
Offer a terse response. 0.19. What is the ratio of the Amount (in current US$) of Indonesia in 1989 to that in 1994?
Ensure brevity in your answer.  0.92. What is the ratio of the Amount (in current US$) of Myanmar in 1989 to that in 1994?
Your answer should be very brief. 6.1. What is the ratio of the Amount (in current US$) of Tanzania in 1989 to that in 1994?
Give a very brief answer. 0.16. What is the ratio of the Amount (in current US$) of Bhutan in 1990 to that in 1991?
Your answer should be compact. 13.43. What is the ratio of the Amount (in current US$) of Indonesia in 1990 to that in 1991?
Offer a very short reply. 0.67. What is the ratio of the Amount (in current US$) of Myanmar in 1990 to that in 1991?
Offer a terse response. 4.82. What is the ratio of the Amount (in current US$) of Tanzania in 1990 to that in 1991?
Offer a very short reply. 5.55. What is the ratio of the Amount (in current US$) in Bhutan in 1990 to that in 1992?
Offer a very short reply. 0.19. What is the ratio of the Amount (in current US$) of Indonesia in 1990 to that in 1992?
Keep it short and to the point. 0.56. What is the ratio of the Amount (in current US$) of Myanmar in 1990 to that in 1992?
Give a very brief answer. 0.65. What is the ratio of the Amount (in current US$) in Tanzania in 1990 to that in 1992?
Ensure brevity in your answer.  0.79. What is the ratio of the Amount (in current US$) of Bhutan in 1990 to that in 1993?
Your response must be concise. 0.17. What is the ratio of the Amount (in current US$) of Indonesia in 1990 to that in 1993?
Provide a short and direct response. 0.87. What is the ratio of the Amount (in current US$) in Myanmar in 1990 to that in 1993?
Provide a short and direct response. 1.94. What is the ratio of the Amount (in current US$) of Bhutan in 1990 to that in 1994?
Provide a short and direct response. 0.25. What is the ratio of the Amount (in current US$) of Indonesia in 1990 to that in 1994?
Offer a terse response. 0.78. What is the ratio of the Amount (in current US$) of Myanmar in 1990 to that in 1994?
Give a very brief answer. 2.12. What is the ratio of the Amount (in current US$) of Tanzania in 1990 to that in 1994?
Provide a succinct answer. 3.06. What is the ratio of the Amount (in current US$) of Bhutan in 1991 to that in 1992?
Offer a very short reply. 0.01. What is the ratio of the Amount (in current US$) of Indonesia in 1991 to that in 1992?
Your answer should be very brief. 0.83. What is the ratio of the Amount (in current US$) of Myanmar in 1991 to that in 1992?
Your answer should be compact. 0.13. What is the ratio of the Amount (in current US$) in Tanzania in 1991 to that in 1992?
Make the answer very short. 0.14. What is the ratio of the Amount (in current US$) in Bhutan in 1991 to that in 1993?
Provide a succinct answer. 0.01. What is the ratio of the Amount (in current US$) in Indonesia in 1991 to that in 1993?
Make the answer very short. 1.3. What is the ratio of the Amount (in current US$) in Myanmar in 1991 to that in 1993?
Give a very brief answer. 0.4. What is the ratio of the Amount (in current US$) in Bhutan in 1991 to that in 1994?
Your response must be concise. 0.02. What is the ratio of the Amount (in current US$) in Indonesia in 1991 to that in 1994?
Your answer should be very brief. 1.16. What is the ratio of the Amount (in current US$) of Myanmar in 1991 to that in 1994?
Ensure brevity in your answer.  0.44. What is the ratio of the Amount (in current US$) of Tanzania in 1991 to that in 1994?
Provide a succinct answer. 0.55. What is the ratio of the Amount (in current US$) in Bhutan in 1992 to that in 1993?
Your response must be concise. 0.88. What is the ratio of the Amount (in current US$) of Indonesia in 1992 to that in 1993?
Your response must be concise. 1.56. What is the ratio of the Amount (in current US$) of Myanmar in 1992 to that in 1993?
Offer a terse response. 3. What is the ratio of the Amount (in current US$) of Bhutan in 1992 to that in 1994?
Your answer should be compact. 1.32. What is the ratio of the Amount (in current US$) in Indonesia in 1992 to that in 1994?
Provide a short and direct response. 1.4. What is the ratio of the Amount (in current US$) in Myanmar in 1992 to that in 1994?
Give a very brief answer. 3.29. What is the ratio of the Amount (in current US$) of Tanzania in 1992 to that in 1994?
Ensure brevity in your answer.  3.87. What is the ratio of the Amount (in current US$) of Bhutan in 1993 to that in 1994?
Provide a short and direct response. 1.5. What is the ratio of the Amount (in current US$) of Indonesia in 1993 to that in 1994?
Provide a succinct answer. 0.89. What is the ratio of the Amount (in current US$) in Myanmar in 1993 to that in 1994?
Give a very brief answer. 1.1. What is the difference between the highest and the second highest Amount (in current US$) in Bhutan?
Give a very brief answer. 1.50e+06. What is the difference between the highest and the second highest Amount (in current US$) in Indonesia?
Ensure brevity in your answer.  3.96e+08. What is the difference between the highest and the second highest Amount (in current US$) of Myanmar?
Your answer should be very brief. 8.43e+06. What is the difference between the highest and the second highest Amount (in current US$) in Tanzania?
Give a very brief answer. 1.77e+07. What is the difference between the highest and the lowest Amount (in current US$) of Bhutan?
Provide a succinct answer. 7.10e+06. What is the difference between the highest and the lowest Amount (in current US$) of Indonesia?
Offer a very short reply. 1.17e+09. What is the difference between the highest and the lowest Amount (in current US$) of Myanmar?
Offer a very short reply. 1.57e+08. What is the difference between the highest and the lowest Amount (in current US$) in Tanzania?
Ensure brevity in your answer.  7.77e+07. 